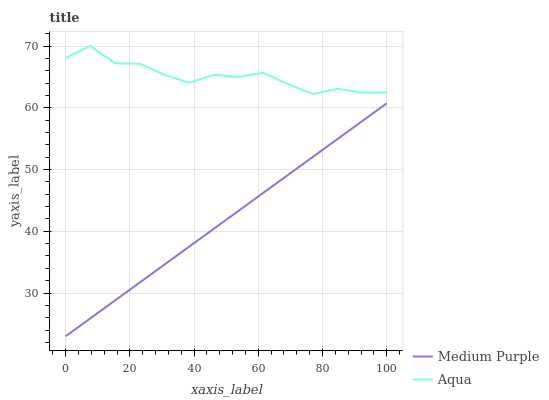Does Aqua have the minimum area under the curve?
Answer yes or no. No. Is Aqua the smoothest?
Answer yes or no. No. Does Aqua have the lowest value?
Answer yes or no. No. Is Medium Purple less than Aqua?
Answer yes or no. Yes. Is Aqua greater than Medium Purple?
Answer yes or no. Yes. Does Medium Purple intersect Aqua?
Answer yes or no. No. 